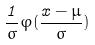<formula> <loc_0><loc_0><loc_500><loc_500>\frac { 1 } { \sigma } \varphi ( \frac { x - \mu } { \sigma } )</formula> 